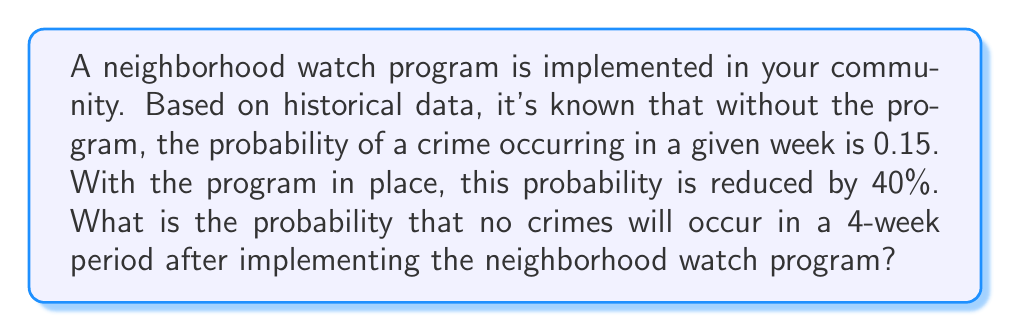Give your solution to this math problem. Let's approach this step-by-step:

1) First, we need to calculate the new probability of a crime occurring in a given week with the neighborhood watch program in place:
   
   Original probability: $p = 0.15$
   Reduction: 40% = 0.4
   
   New probability: $p_{new} = p - (0.4 \times p) = 0.15 - (0.4 \times 0.15) = 0.15 - 0.06 = 0.09$

2) Now, we want to find the probability of no crimes occurring in a 4-week period. This is equivalent to the probability of no crimes occurring in each of the 4 weeks.

3) The probability of no crime occurring in a single week is the complement of the probability of a crime occurring:
   
   $P(\text{no crime in one week}) = 1 - p_{new} = 1 - 0.09 = 0.91$

4) For no crimes to occur in 4 weeks, we need this to happen 4 times in a row. Assuming the events are independent, we can use the multiplication rule of probability:

   $P(\text{no crime in 4 weeks}) = (0.91)^4$

5) Calculate the final probability:
   
   $$(0.91)^4 = 0.6860$$
Answer: $0.6860$ or $68.60\%$ 